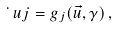<formula> <loc_0><loc_0><loc_500><loc_500>\dot { \ } u j = g _ { j } ( \vec { u } , \gamma ) \, ,</formula> 